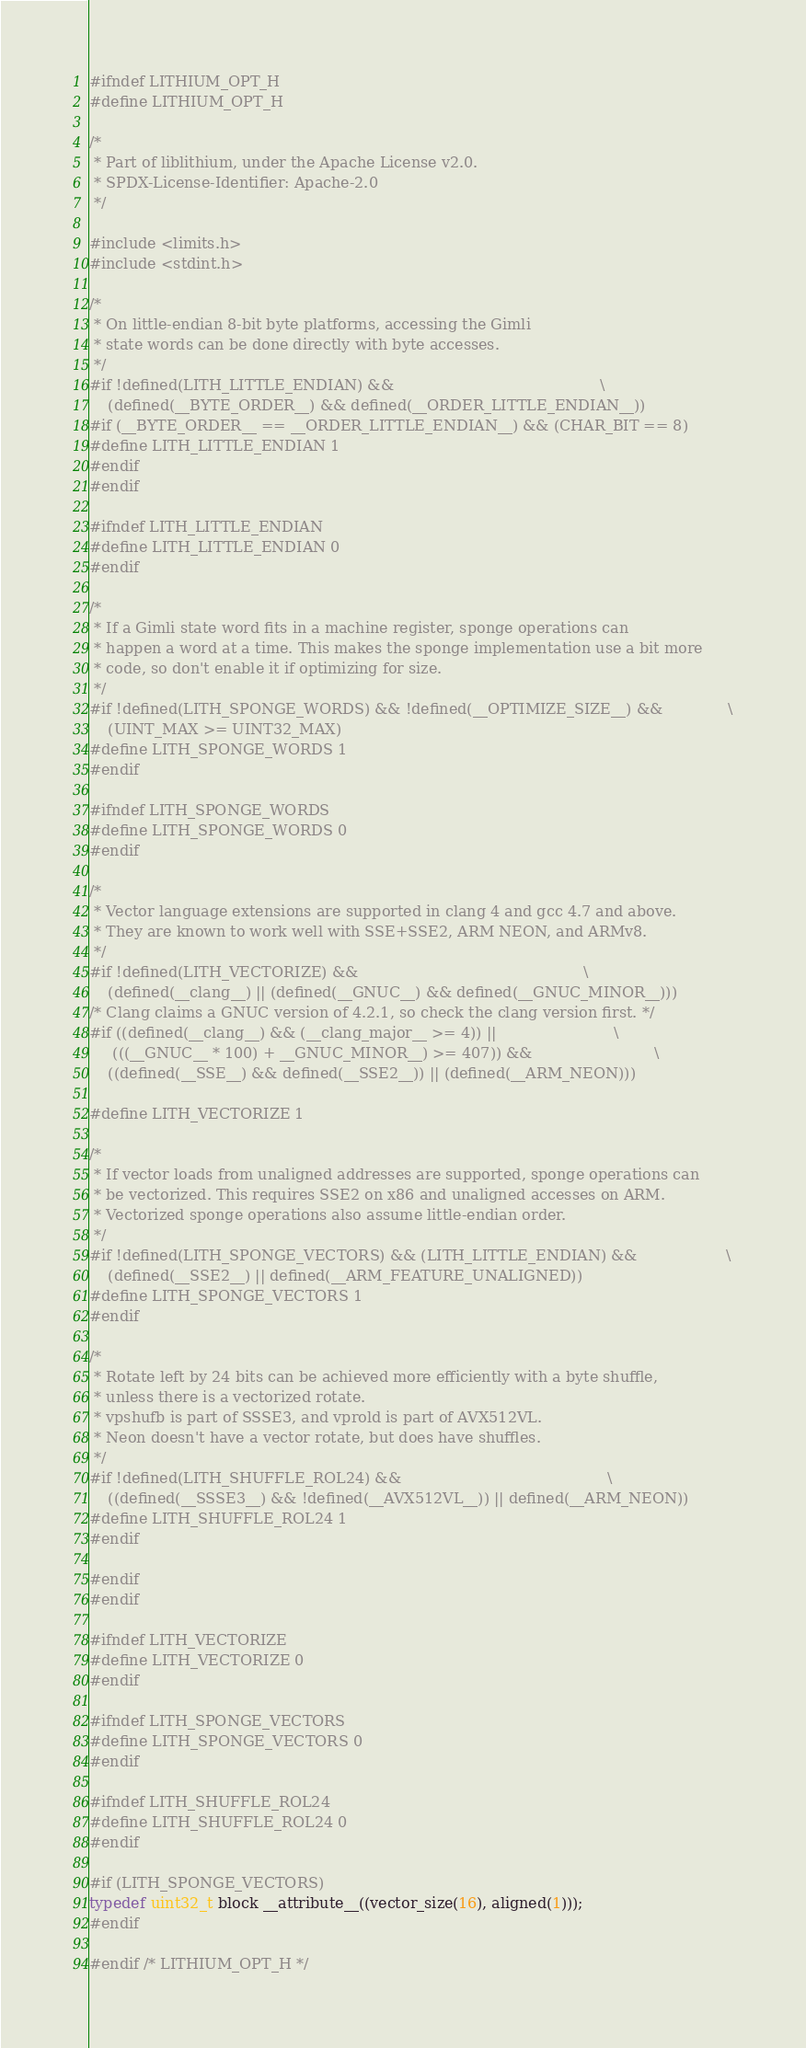Convert code to text. <code><loc_0><loc_0><loc_500><loc_500><_C_>#ifndef LITHIUM_OPT_H
#define LITHIUM_OPT_H

/*
 * Part of liblithium, under the Apache License v2.0.
 * SPDX-License-Identifier: Apache-2.0
 */

#include <limits.h>
#include <stdint.h>

/*
 * On little-endian 8-bit byte platforms, accessing the Gimli
 * state words can be done directly with byte accesses.
 */
#if !defined(LITH_LITTLE_ENDIAN) &&                                            \
    (defined(__BYTE_ORDER__) && defined(__ORDER_LITTLE_ENDIAN__))
#if (__BYTE_ORDER__ == __ORDER_LITTLE_ENDIAN__) && (CHAR_BIT == 8)
#define LITH_LITTLE_ENDIAN 1
#endif
#endif

#ifndef LITH_LITTLE_ENDIAN
#define LITH_LITTLE_ENDIAN 0
#endif

/*
 * If a Gimli state word fits in a machine register, sponge operations can
 * happen a word at a time. This makes the sponge implementation use a bit more
 * code, so don't enable it if optimizing for size.
 */
#if !defined(LITH_SPONGE_WORDS) && !defined(__OPTIMIZE_SIZE__) &&              \
    (UINT_MAX >= UINT32_MAX)
#define LITH_SPONGE_WORDS 1
#endif

#ifndef LITH_SPONGE_WORDS
#define LITH_SPONGE_WORDS 0
#endif

/*
 * Vector language extensions are supported in clang 4 and gcc 4.7 and above.
 * They are known to work well with SSE+SSE2, ARM NEON, and ARMv8.
 */
#if !defined(LITH_VECTORIZE) &&                                                \
    (defined(__clang__) || (defined(__GNUC__) && defined(__GNUC_MINOR__)))
/* Clang claims a GNUC version of 4.2.1, so check the clang version first. */
#if ((defined(__clang__) && (__clang_major__ >= 4)) ||                         \
     (((__GNUC__ * 100) + __GNUC_MINOR__) >= 407)) &&                          \
    ((defined(__SSE__) && defined(__SSE2__)) || (defined(__ARM_NEON)))

#define LITH_VECTORIZE 1

/*
 * If vector loads from unaligned addresses are supported, sponge operations can
 * be vectorized. This requires SSE2 on x86 and unaligned accesses on ARM.
 * Vectorized sponge operations also assume little-endian order.
 */
#if !defined(LITH_SPONGE_VECTORS) && (LITH_LITTLE_ENDIAN) &&                   \
    (defined(__SSE2__) || defined(__ARM_FEATURE_UNALIGNED))
#define LITH_SPONGE_VECTORS 1
#endif

/*
 * Rotate left by 24 bits can be achieved more efficiently with a byte shuffle,
 * unless there is a vectorized rotate.
 * vpshufb is part of SSSE3, and vprold is part of AVX512VL.
 * Neon doesn't have a vector rotate, but does have shuffles.
 */
#if !defined(LITH_SHUFFLE_ROL24) &&                                            \
    ((defined(__SSSE3__) && !defined(__AVX512VL__)) || defined(__ARM_NEON))
#define LITH_SHUFFLE_ROL24 1
#endif

#endif
#endif

#ifndef LITH_VECTORIZE
#define LITH_VECTORIZE 0
#endif

#ifndef LITH_SPONGE_VECTORS
#define LITH_SPONGE_VECTORS 0
#endif

#ifndef LITH_SHUFFLE_ROL24
#define LITH_SHUFFLE_ROL24 0
#endif

#if (LITH_SPONGE_VECTORS)
typedef uint32_t block __attribute__((vector_size(16), aligned(1)));
#endif

#endif /* LITHIUM_OPT_H */
</code> 